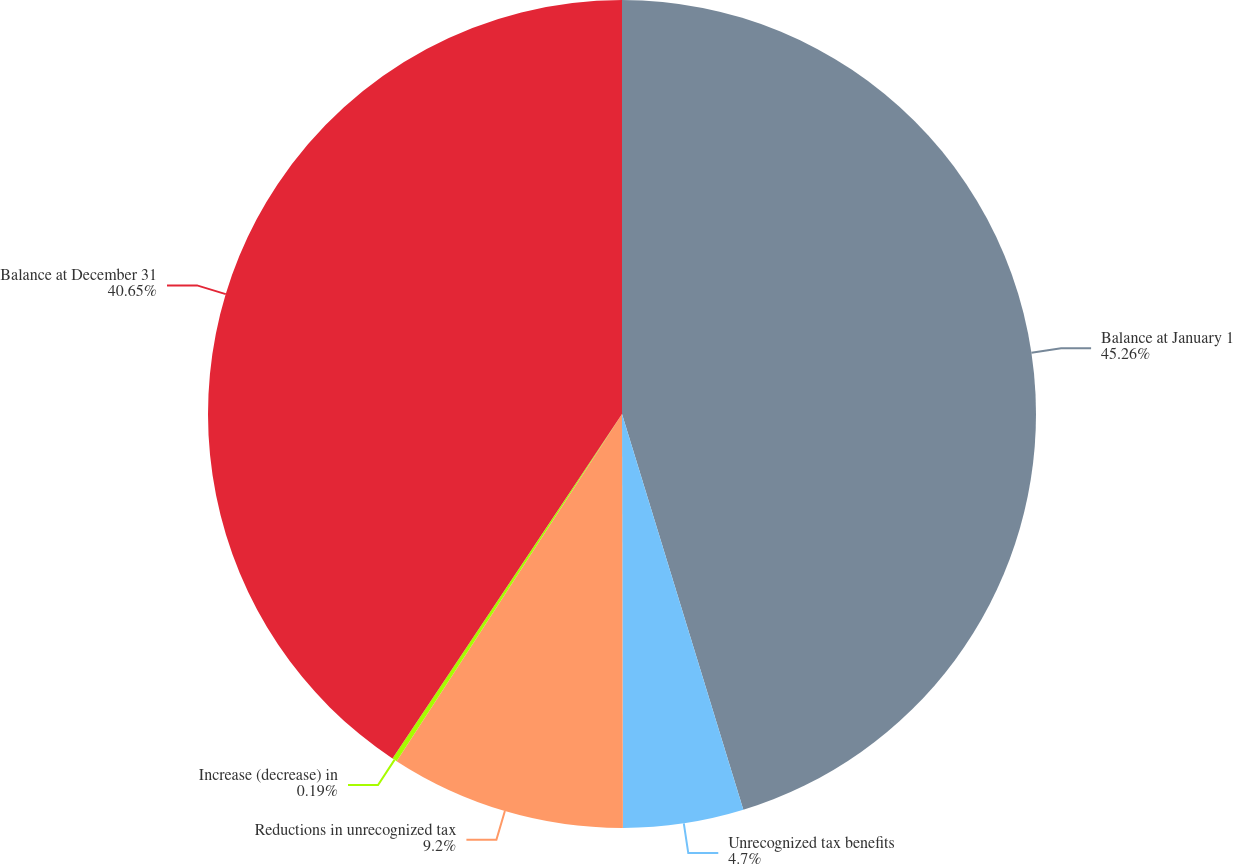<chart> <loc_0><loc_0><loc_500><loc_500><pie_chart><fcel>Balance at January 1<fcel>Unrecognized tax benefits<fcel>Reductions in unrecognized tax<fcel>Increase (decrease) in<fcel>Balance at December 31<nl><fcel>45.27%<fcel>4.7%<fcel>9.2%<fcel>0.19%<fcel>40.65%<nl></chart> 